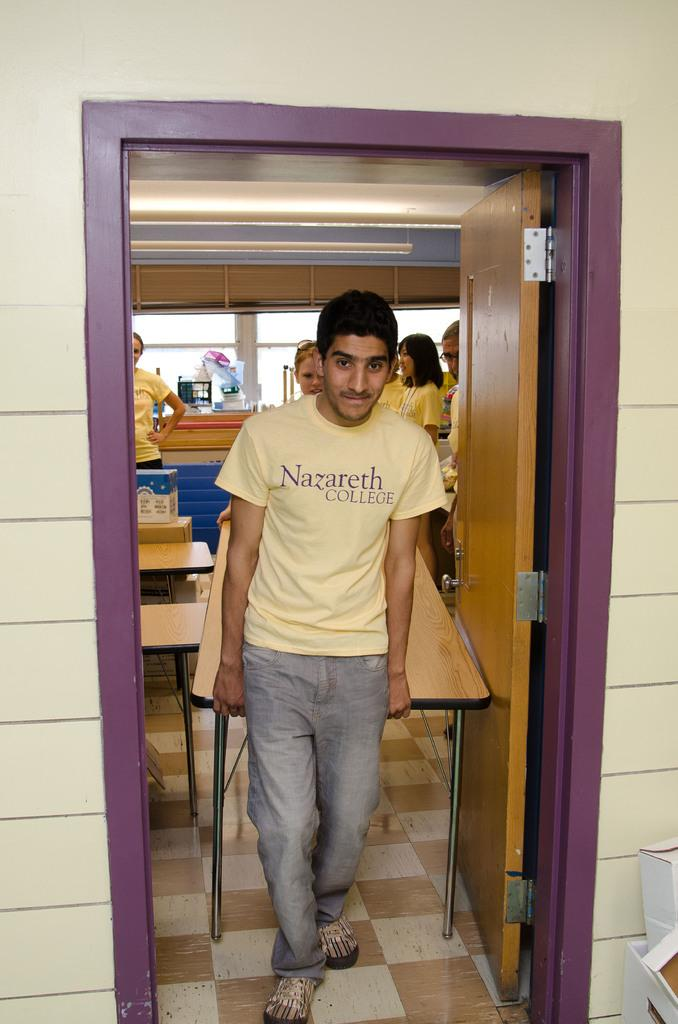What is the main subject of the image? There is a man in the image. What is the man doing in the image? The man is standing and holding a table. Can you describe the background of the image? There are many people in the background of the image. How many horses are present in the image? There are no horses present in the image. What degree does the man in the image have? The provided facts do not mention the man's degree, so we cannot answer this question. 